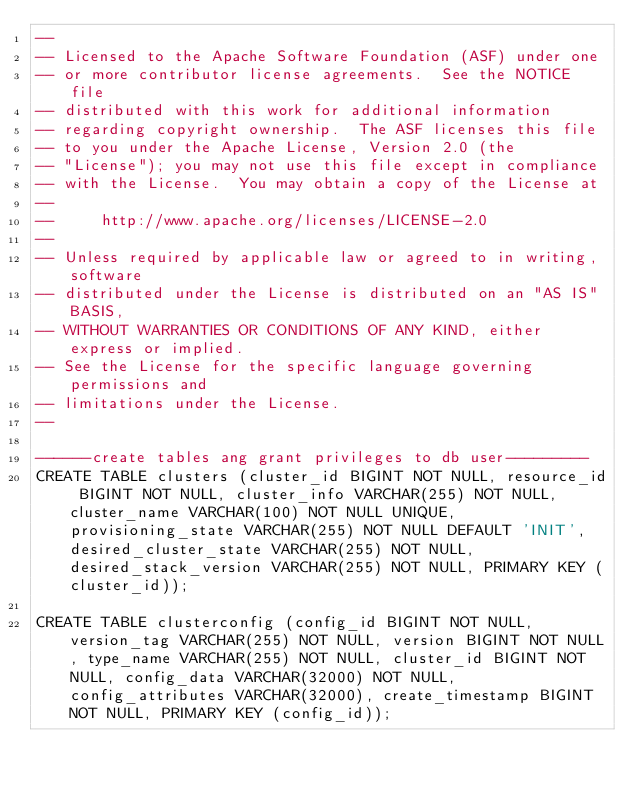Convert code to text. <code><loc_0><loc_0><loc_500><loc_500><_SQL_>--
-- Licensed to the Apache Software Foundation (ASF) under one
-- or more contributor license agreements.  See the NOTICE file
-- distributed with this work for additional information
-- regarding copyright ownership.  The ASF licenses this file
-- to you under the Apache License, Version 2.0 (the
-- "License"); you may not use this file except in compliance
-- with the License.  You may obtain a copy of the License at
--
--     http://www.apache.org/licenses/LICENSE-2.0
--
-- Unless required by applicable law or agreed to in writing, software
-- distributed under the License is distributed on an "AS IS" BASIS,
-- WITHOUT WARRANTIES OR CONDITIONS OF ANY KIND, either express or implied.
-- See the License for the specific language governing permissions and
-- limitations under the License.
--

------create tables ang grant privileges to db user---------
CREATE TABLE clusters (cluster_id BIGINT NOT NULL, resource_id BIGINT NOT NULL, cluster_info VARCHAR(255) NOT NULL, cluster_name VARCHAR(100) NOT NULL UNIQUE, provisioning_state VARCHAR(255) NOT NULL DEFAULT 'INIT', desired_cluster_state VARCHAR(255) NOT NULL, desired_stack_version VARCHAR(255) NOT NULL, PRIMARY KEY (cluster_id));

CREATE TABLE clusterconfig (config_id BIGINT NOT NULL, version_tag VARCHAR(255) NOT NULL, version BIGINT NOT NULL, type_name VARCHAR(255) NOT NULL, cluster_id BIGINT NOT NULL, config_data VARCHAR(32000) NOT NULL, config_attributes VARCHAR(32000), create_timestamp BIGINT NOT NULL, PRIMARY KEY (config_id));
</code> 